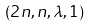<formula> <loc_0><loc_0><loc_500><loc_500>( 2 n , n , \lambda , 1 )</formula> 